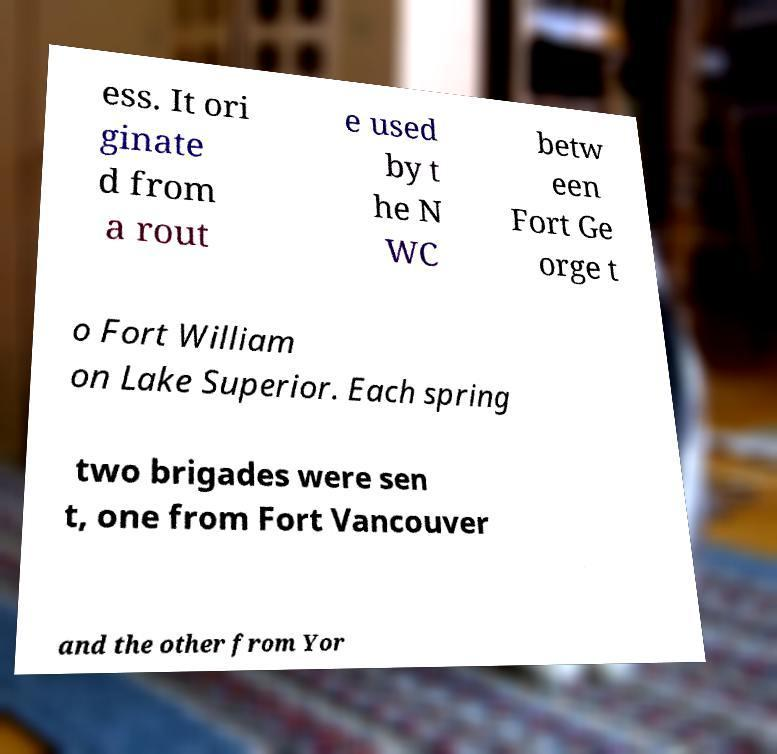Can you accurately transcribe the text from the provided image for me? ess. It ori ginate d from a rout e used by t he N WC betw een Fort Ge orge t o Fort William on Lake Superior. Each spring two brigades were sen t, one from Fort Vancouver and the other from Yor 